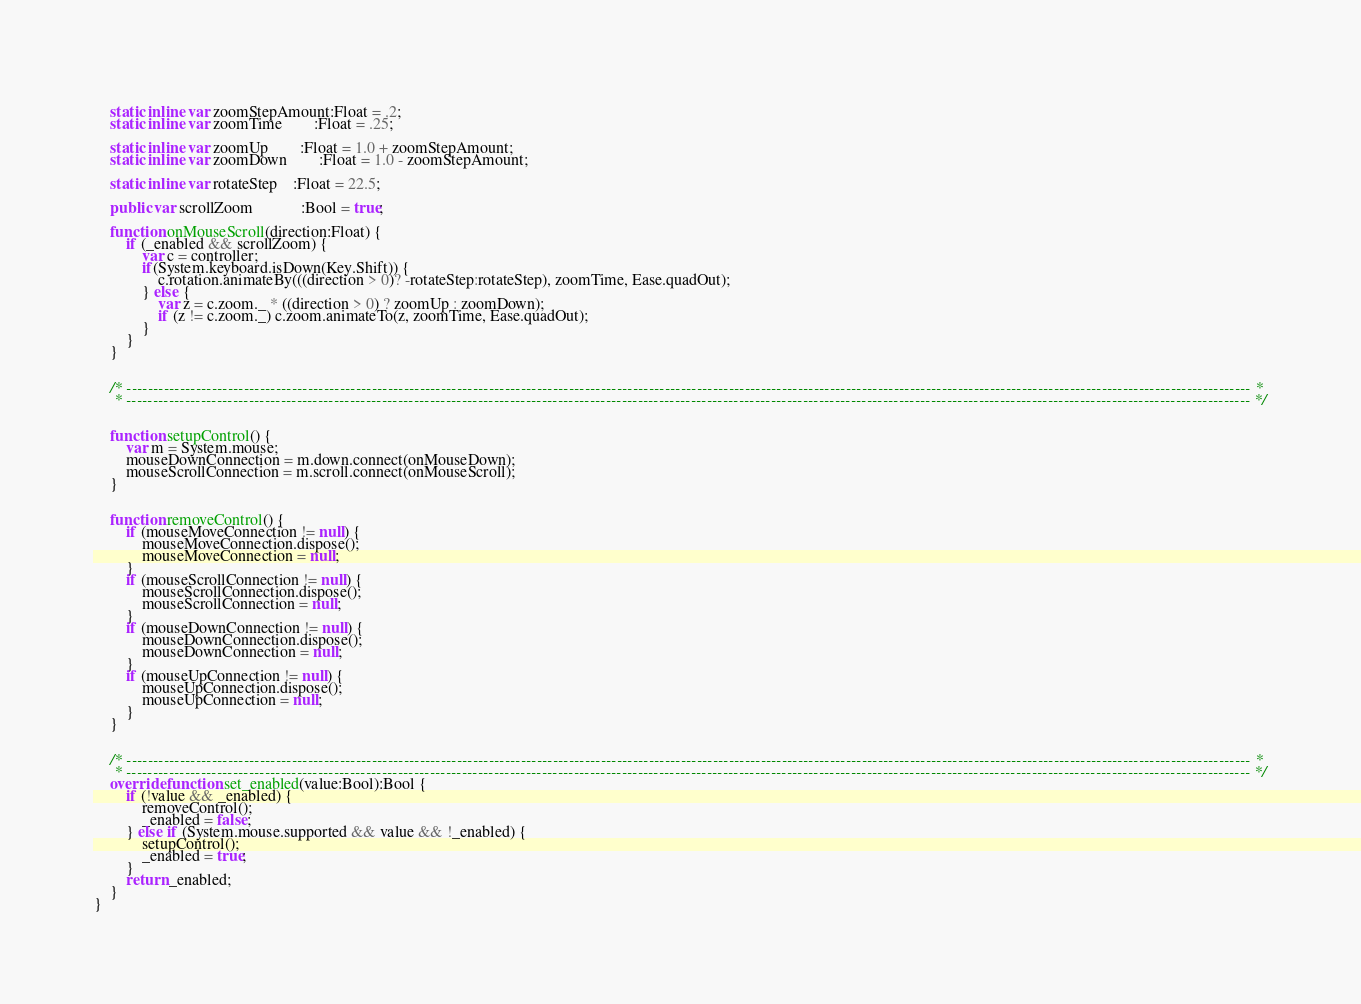Convert code to text. <code><loc_0><loc_0><loc_500><loc_500><_Haxe_>	
	static inline var zoomStepAmount:Float = .2;
	static inline var zoomTime		:Float = .25;
	
	static inline var zoomUp		:Float = 1.0 + zoomStepAmount;
	static inline var zoomDown		:Float = 1.0 - zoomStepAmount;
	
	static inline var rotateStep	:Float = 22.5;
	
	public var scrollZoom			:Bool = true;
	
	function onMouseScroll(direction:Float) {
		if (_enabled && scrollZoom) {
			var c = controller;
			if(System.keyboard.isDown(Key.Shift)) {
				c.rotation.animateBy(((direction > 0)? -rotateStep:rotateStep), zoomTime, Ease.quadOut);
			} else {
				var z = c.zoom._ * ((direction > 0) ? zoomUp : zoomDown);
				if (z != c.zoom._) c.zoom.animateTo(z, zoomTime, Ease.quadOut);
			}
		}
	}
	
	
	/* ------------------------------------------------------------------------------------------------------------------------------------------------------------------------------------------------------------------- *
	 * ------------------------------------------------------------------------------------------------------------------------------------------------------------------------------------------------------------------- */
	
	
	function setupControl() {
		var m = System.mouse;
		mouseDownConnection = m.down.connect(onMouseDown);
		mouseScrollConnection = m.scroll.connect(onMouseScroll);
	}
	
	
	function removeControl() {
		if (mouseMoveConnection != null) {
			mouseMoveConnection.dispose();
			mouseMoveConnection = null;
		}
		if (mouseScrollConnection != null) {
			mouseScrollConnection.dispose(); 
			mouseScrollConnection = null;
		}
		if (mouseDownConnection != null) {
			mouseDownConnection.dispose(); 
			mouseDownConnection = null;
		}
		if (mouseUpConnection != null) {
			mouseUpConnection.dispose(); 
			mouseUpConnection = null;
		}
	}
	
	
	/* ------------------------------------------------------------------------------------------------------------------------------------------------------------------------------------------------------------------- *
	 * ------------------------------------------------------------------------------------------------------------------------------------------------------------------------------------------------------------------- */
	override function set_enabled(value:Bool):Bool {
		if (!value && _enabled) {
			removeControl();
			_enabled = false;
		} else if (System.mouse.supported && value && !_enabled) {
			setupControl();			
			_enabled = true;
		}
		return _enabled;
	}
}</code> 